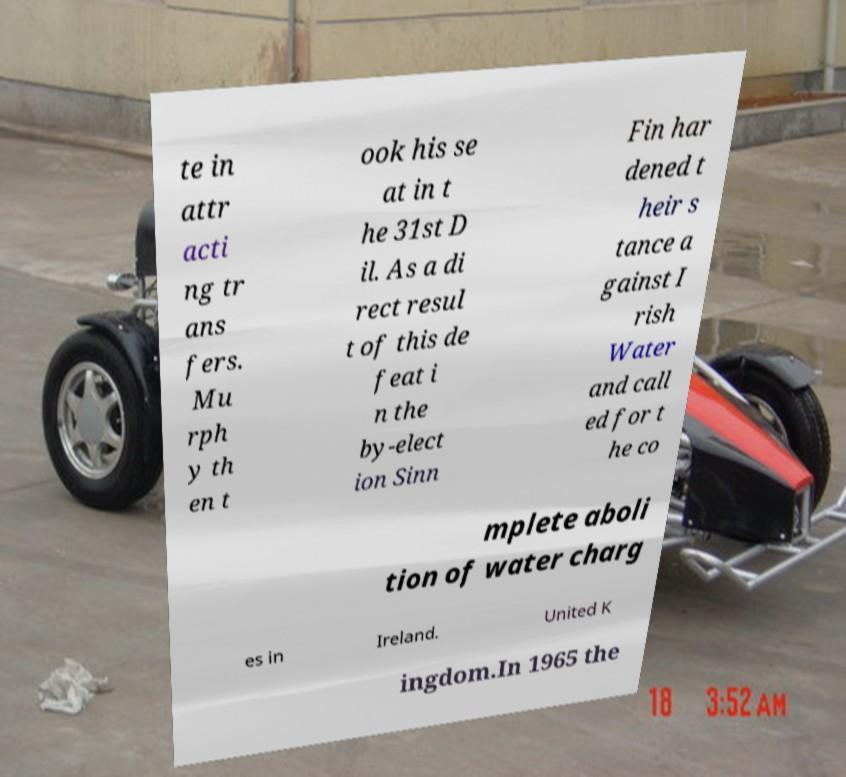For documentation purposes, I need the text within this image transcribed. Could you provide that? te in attr acti ng tr ans fers. Mu rph y th en t ook his se at in t he 31st D il. As a di rect resul t of this de feat i n the by-elect ion Sinn Fin har dened t heir s tance a gainst I rish Water and call ed for t he co mplete aboli tion of water charg es in Ireland. United K ingdom.In 1965 the 